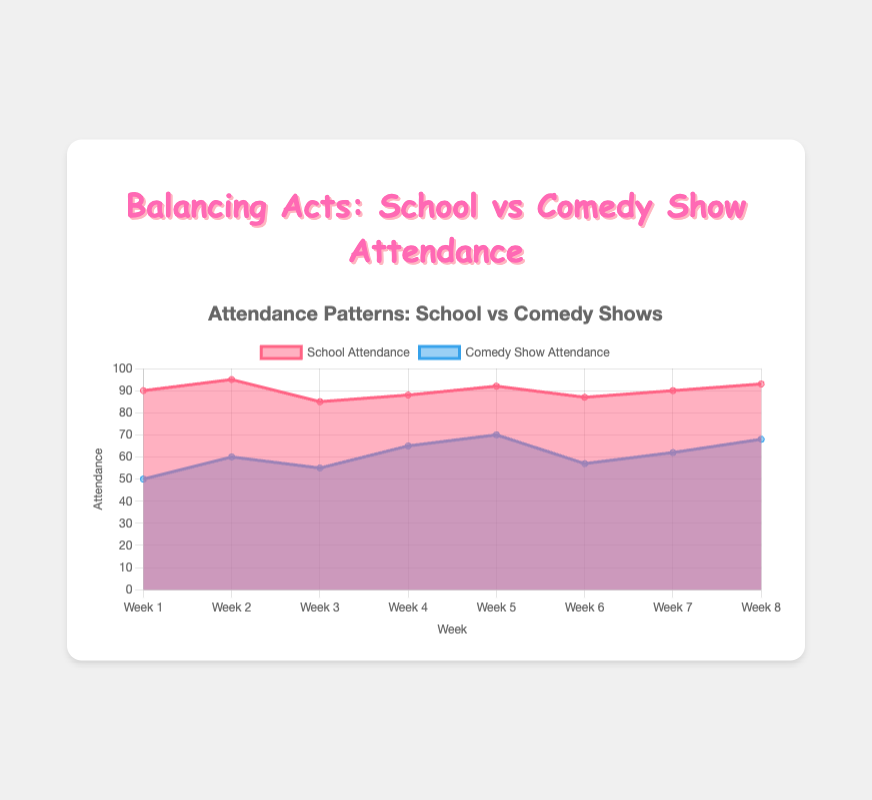What's the title of the figure? The title is usually placed at the top of the figure and in this case, it is clearly displayed above the chart.
Answer: Balancing Acts: School vs Comedy Show Attendance How many weeks are displayed in the chart? The x-axis of the chart, labeled 'Week', shows the data points for each week. By counting them, we can determine the number of weeks.
Answer: 8 What is the school attendance for Week 5? Locate 'Week 5' on the x-axis, then check the value of the 'School Attendance' line.
Answer: 92 What color represents comedy show attendance? Each dataset is represented by a specific color and stated in the legend. The 'Comedy Show Attendance' line is clearly indicated with a blue color.
Answer: Blue Which week had the highest comedy show attendance? By looking at the peaks of the blue area for each week, we can identify the highest comedy show attendance.
Answer: Week 5 What is the average school attendance over the 8 weeks? Sum the school attendance values for all weeks and divide by 8 (90 + 95 + 85 + 88 + 92 + 87 + 90 + 93) / 8 = 720 / 8.
Answer: 90 Is there a week when school attendance is equal to comedy show attendance? Compare each week’s school attendance value (red area) to the corresponding comedy show attendance value (blue area).
Answer: No What week shows the biggest gap between school and comedy show attendance? Calculate the difference between school and comedy show attendance for each week and find the highest difference. Week 5 shows the highest difference (92 - 70 = 22).
Answer: Week 5 Is there a correlation between school attendance and comedy show attendance? Analyze the trend lines for both datasets to see if increases or decreases in one correspond with the other. Generally, as school attendance increases, comedy show attendance also tends to increase, indicating a potential positive correlation.
Answer: Yes, positive correlation On average, is the school attendance higher than the comedy show attendance? Calculate the average attendance for both school and comedy shows. The average school attendance is 90, while the average comedy show attendance is (50 + 60 + 55 + 65 + 70 + 57 + 62 + 68) / 8 = 59.625. Since 90 is greater than 59.625, school attendance is higher on average.
Answer: Yes 